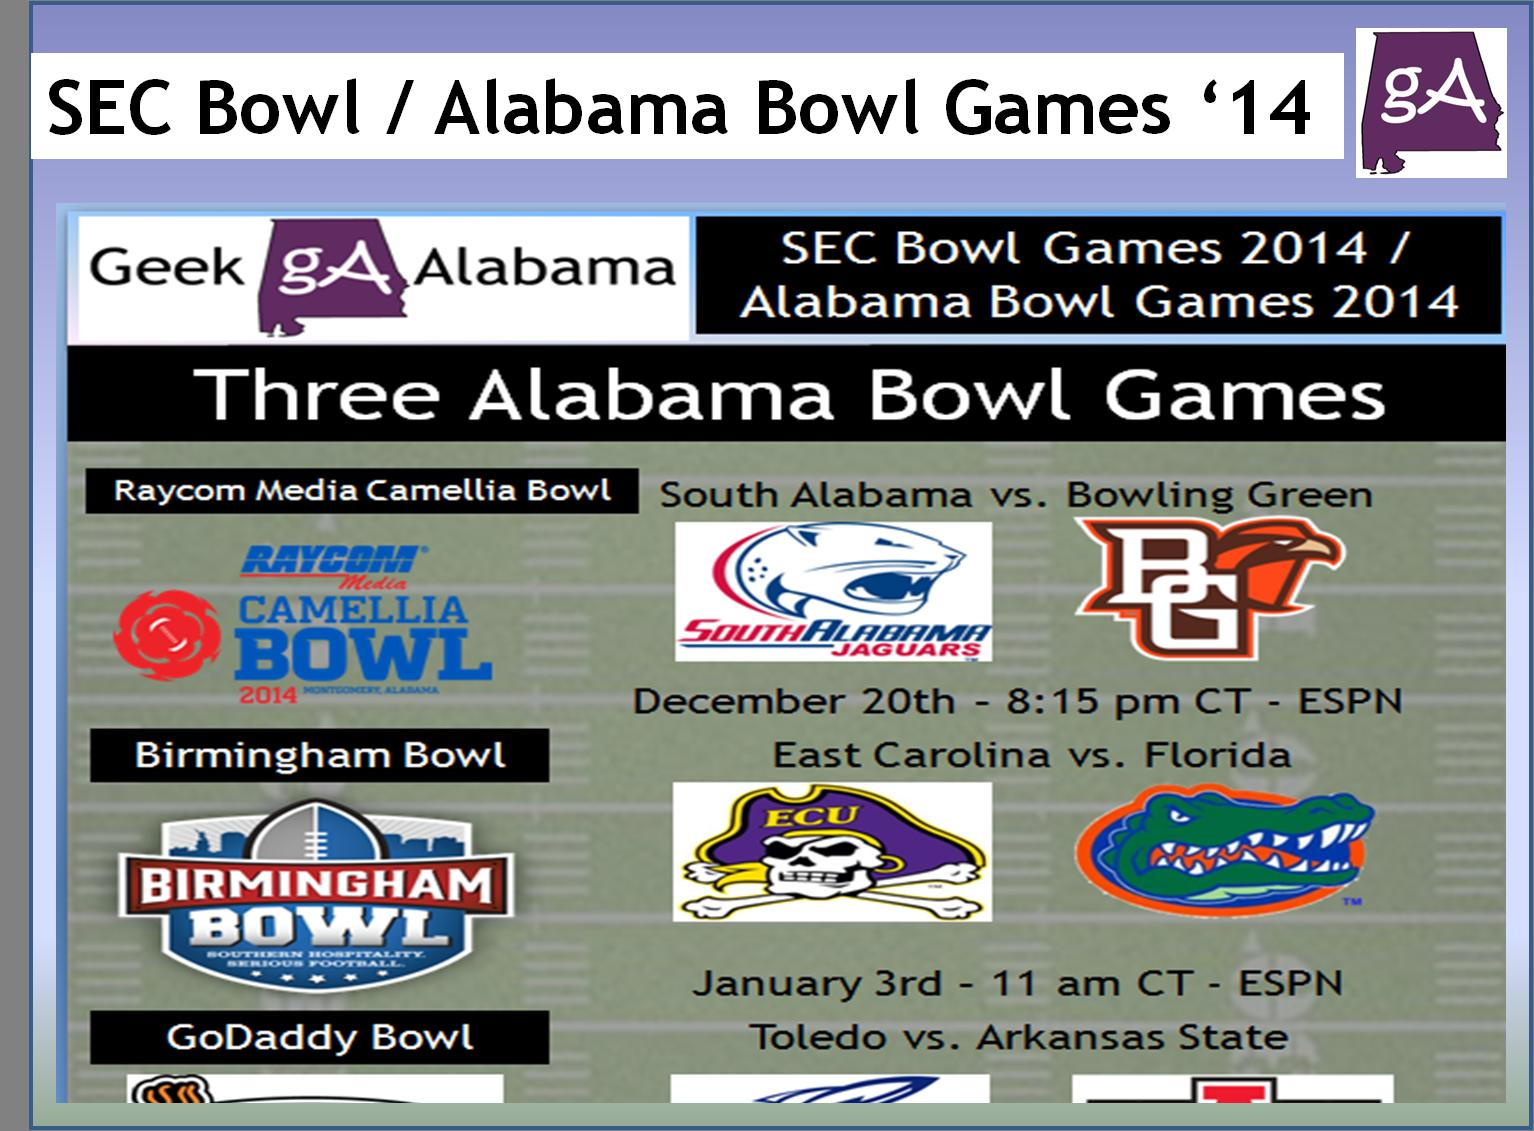Highlight a few significant elements in this photo. The Birmingham Bowl match will be held on January 3rd. The Raycom Media Camellia Bowl match will be broadcast at 8:15 pm Central Time. The Raycom Media Camelia Bowl match will take place on December 20th at 8:15 pm CT. On January 3rd, East Carolina will compete against Florida in a thrilling match. The Raycom Media Camelia Bowl will be broadcast on ESPN. 